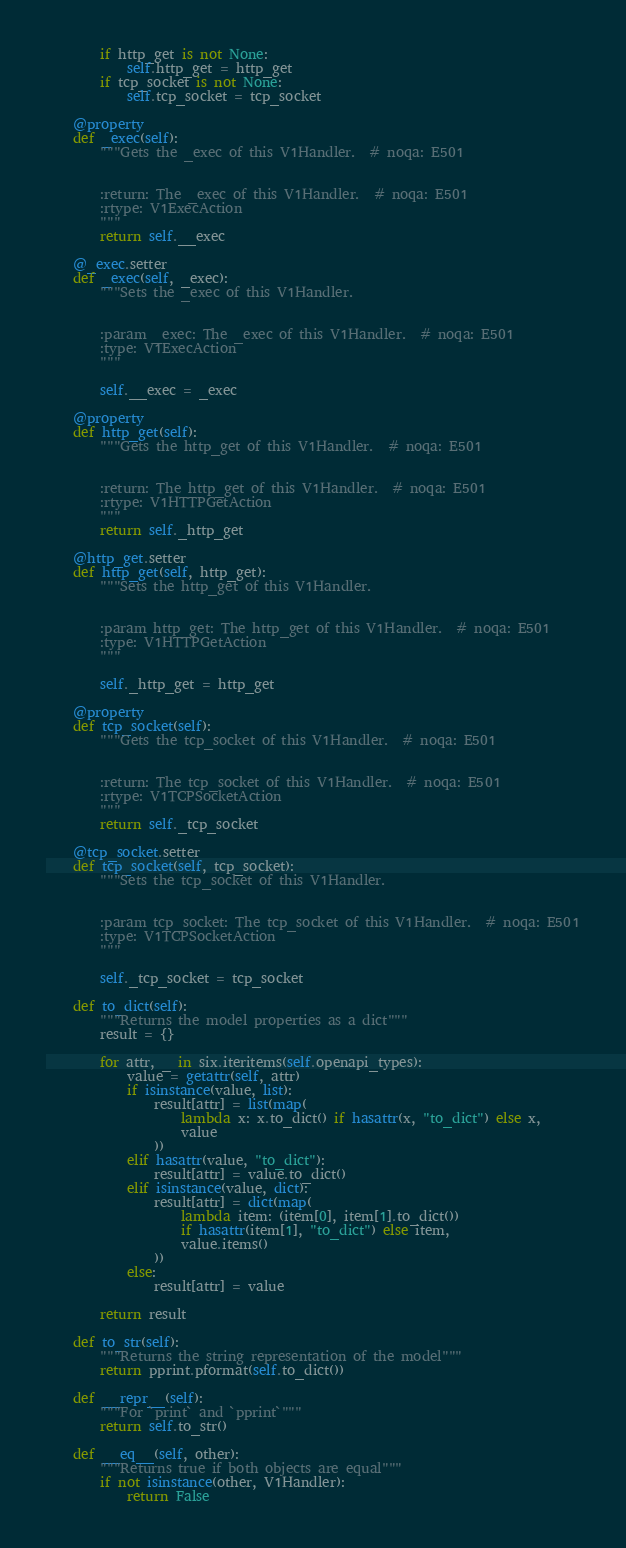<code> <loc_0><loc_0><loc_500><loc_500><_Python_>        if http_get is not None:
            self.http_get = http_get
        if tcp_socket is not None:
            self.tcp_socket = tcp_socket

    @property
    def _exec(self):
        """Gets the _exec of this V1Handler.  # noqa: E501


        :return: The _exec of this V1Handler.  # noqa: E501
        :rtype: V1ExecAction
        """
        return self.__exec

    @_exec.setter
    def _exec(self, _exec):
        """Sets the _exec of this V1Handler.


        :param _exec: The _exec of this V1Handler.  # noqa: E501
        :type: V1ExecAction
        """

        self.__exec = _exec

    @property
    def http_get(self):
        """Gets the http_get of this V1Handler.  # noqa: E501


        :return: The http_get of this V1Handler.  # noqa: E501
        :rtype: V1HTTPGetAction
        """
        return self._http_get

    @http_get.setter
    def http_get(self, http_get):
        """Sets the http_get of this V1Handler.


        :param http_get: The http_get of this V1Handler.  # noqa: E501
        :type: V1HTTPGetAction
        """

        self._http_get = http_get

    @property
    def tcp_socket(self):
        """Gets the tcp_socket of this V1Handler.  # noqa: E501


        :return: The tcp_socket of this V1Handler.  # noqa: E501
        :rtype: V1TCPSocketAction
        """
        return self._tcp_socket

    @tcp_socket.setter
    def tcp_socket(self, tcp_socket):
        """Sets the tcp_socket of this V1Handler.


        :param tcp_socket: The tcp_socket of this V1Handler.  # noqa: E501
        :type: V1TCPSocketAction
        """

        self._tcp_socket = tcp_socket

    def to_dict(self):
        """Returns the model properties as a dict"""
        result = {}

        for attr, _ in six.iteritems(self.openapi_types):
            value = getattr(self, attr)
            if isinstance(value, list):
                result[attr] = list(map(
                    lambda x: x.to_dict() if hasattr(x, "to_dict") else x,
                    value
                ))
            elif hasattr(value, "to_dict"):
                result[attr] = value.to_dict()
            elif isinstance(value, dict):
                result[attr] = dict(map(
                    lambda item: (item[0], item[1].to_dict())
                    if hasattr(item[1], "to_dict") else item,
                    value.items()
                ))
            else:
                result[attr] = value

        return result

    def to_str(self):
        """Returns the string representation of the model"""
        return pprint.pformat(self.to_dict())

    def __repr__(self):
        """For `print` and `pprint`"""
        return self.to_str()

    def __eq__(self, other):
        """Returns true if both objects are equal"""
        if not isinstance(other, V1Handler):
            return False
</code> 